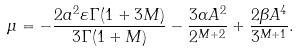<formula> <loc_0><loc_0><loc_500><loc_500>\mu = - \frac { 2 a ^ { 2 } \varepsilon \Gamma ( 1 + 3 M ) } { 3 \Gamma ( 1 + M ) } - \frac { 3 \alpha A ^ { 2 } } { 2 ^ { M + 2 } } + \frac { 2 \beta A ^ { 4 } } { 3 ^ { M + 1 } } .</formula> 